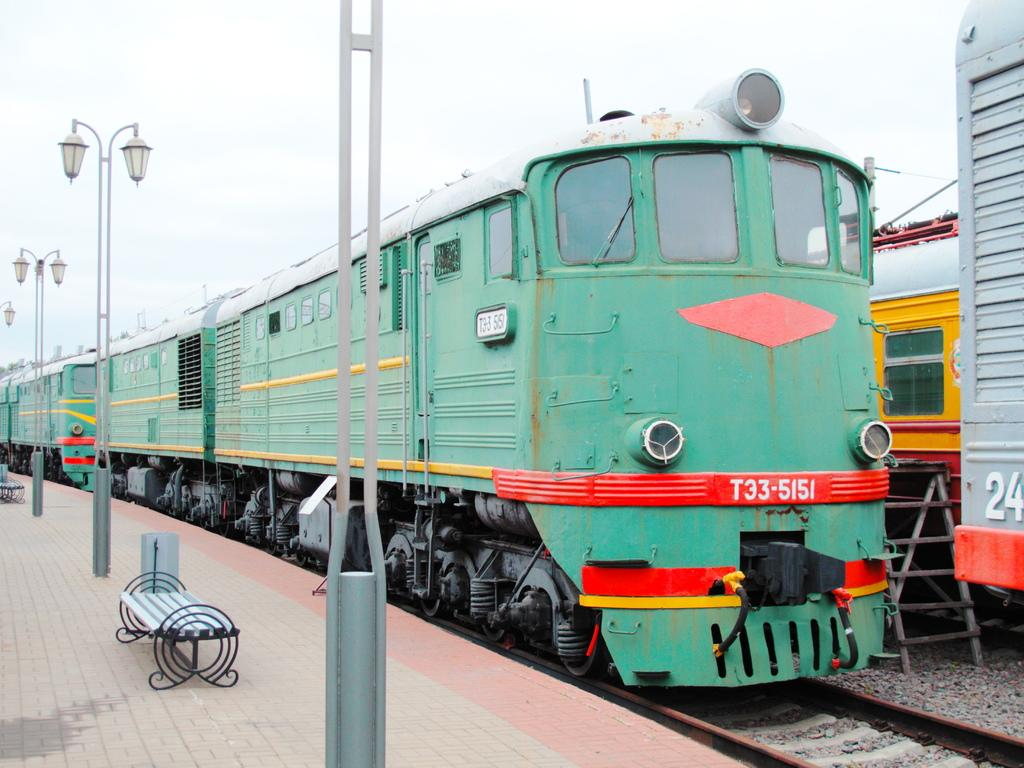<image>
Create a compact narrative representing the image presented. A green train numbered T35-5151 is parked near other trains. 